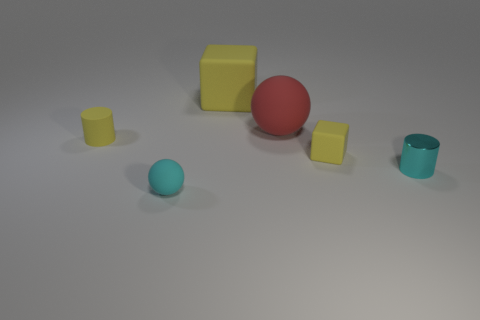What number of tiny yellow things are there?
Provide a short and direct response. 2. There is a yellow matte thing that is left of the matte block that is behind the small yellow thing that is left of the large yellow cube; what size is it?
Ensure brevity in your answer.  Small. Do the tiny matte ball and the tiny metallic cylinder have the same color?
Give a very brief answer. Yes. How many big red spheres are in front of the cyan metal cylinder?
Give a very brief answer. 0. Is the number of tiny matte objects that are behind the big yellow rubber thing the same as the number of small cyan cylinders?
Give a very brief answer. No. What number of things are large rubber objects or small yellow matte cylinders?
Provide a succinct answer. 3. Is there anything else that has the same shape as the metal thing?
Make the answer very short. Yes. What shape is the big rubber object behind the big red rubber ball that is to the right of the big yellow rubber object?
Give a very brief answer. Cube. The tiny yellow thing that is made of the same material as the small cube is what shape?
Your answer should be very brief. Cylinder. There is a ball that is on the right side of the cyan object that is in front of the small cyan cylinder; what is its size?
Give a very brief answer. Large. 